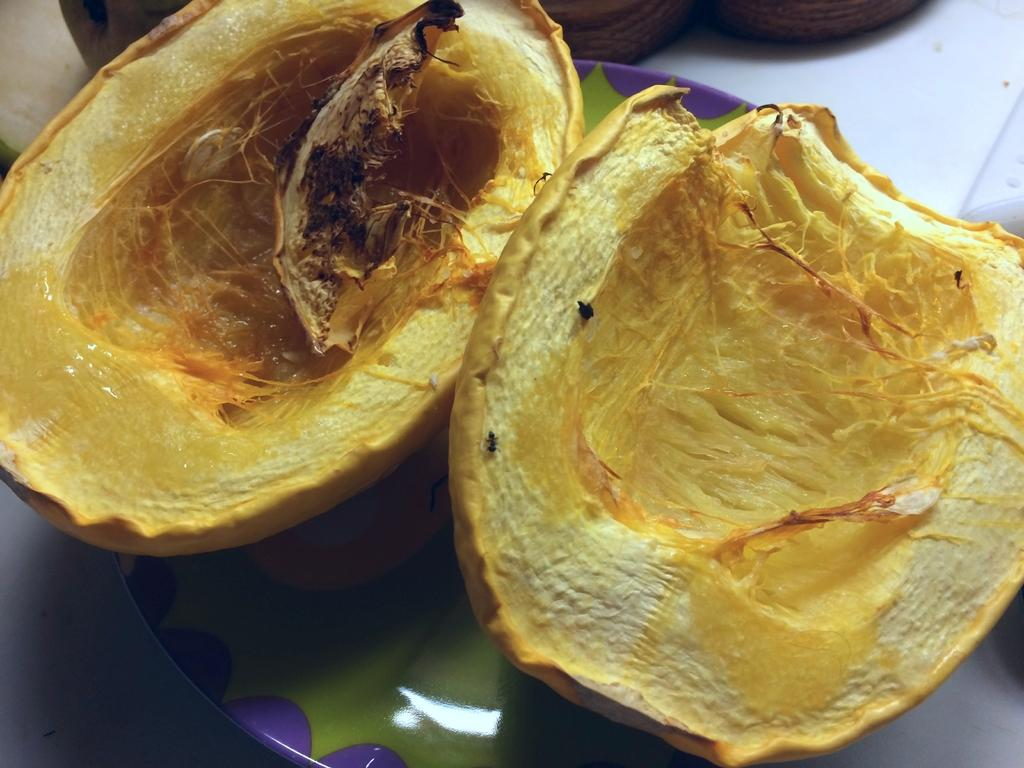What type of food can be seen in the image? There are fruits in a plate in the image. Can you describe the arrangement of the fruits on the plate? The provided facts do not specify the arrangement of the fruits on the plate. What might someone do with the fruits in the image? Someone might eat the fruits or use them for decoration. Who is the uncle kissing in the image? There is no uncle or kissing depicted in the image; it only shows fruits in a plate. 